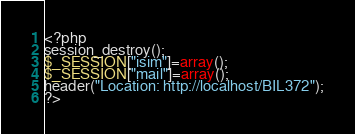<code> <loc_0><loc_0><loc_500><loc_500><_PHP_><?php
session_destroy();
$_SESSION["isim"]=array();
$_SESSION["mail"]=array();
header("Location: http://localhost/BIL372");
?></code> 